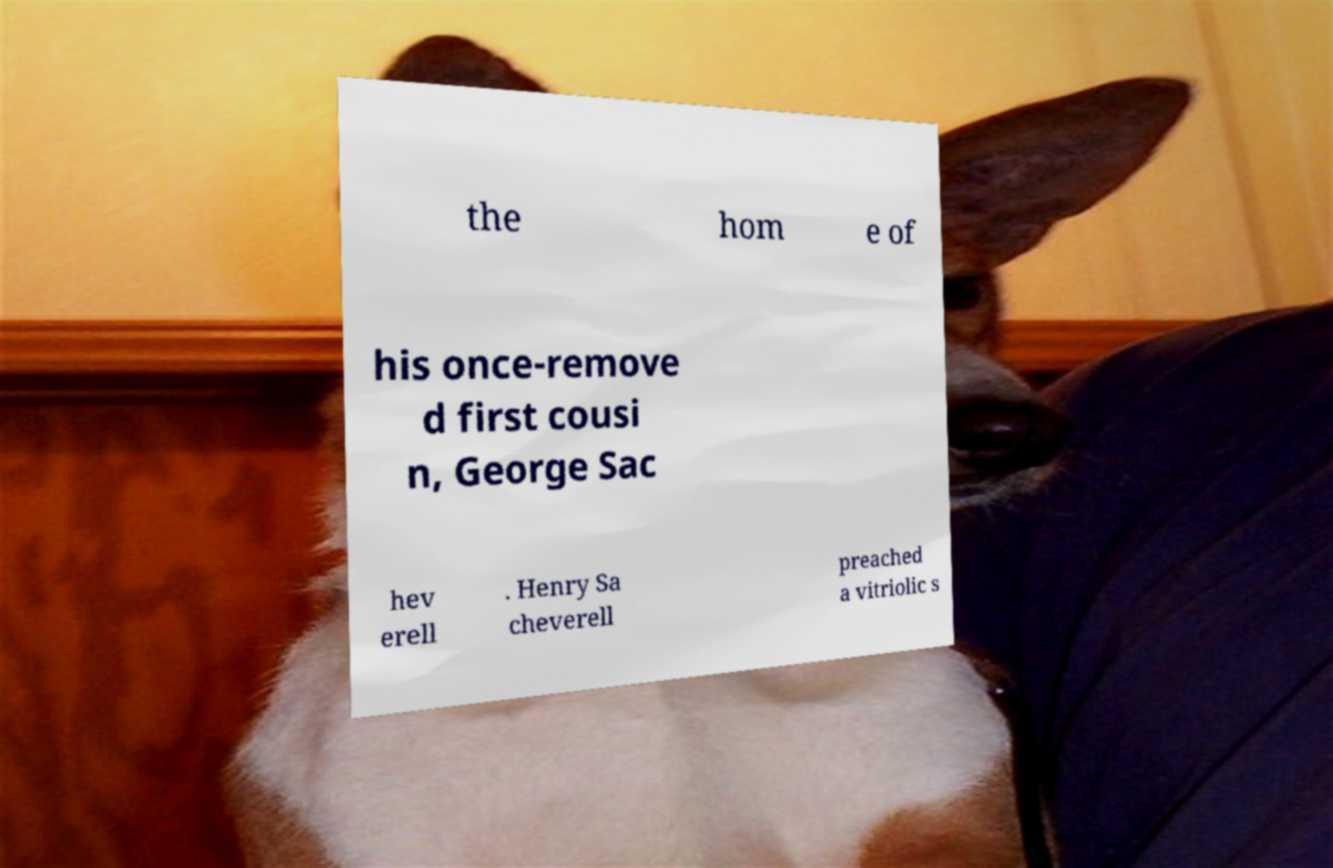Could you extract and type out the text from this image? the hom e of his once-remove d first cousi n, George Sac hev erell . Henry Sa cheverell preached a vitriolic s 